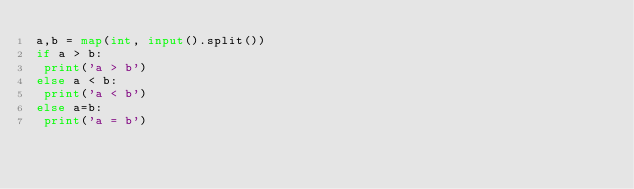Convert code to text. <code><loc_0><loc_0><loc_500><loc_500><_Python_>a,b = map(int, input().split())
if a > b:
 print('a > b')
else a < b:
 print('a < b')
else a=b:
 print('a = b')</code> 